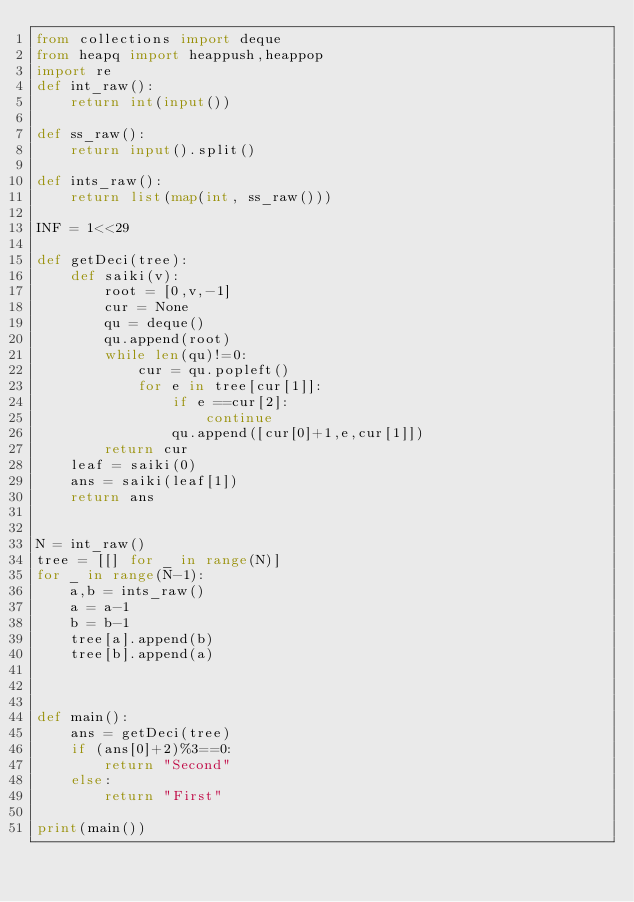Convert code to text. <code><loc_0><loc_0><loc_500><loc_500><_Python_>from collections import deque
from heapq import heappush,heappop
import re
def int_raw():
    return int(input())

def ss_raw():
    return input().split()

def ints_raw():
    return list(map(int, ss_raw()))

INF = 1<<29

def getDeci(tree):
    def saiki(v):
        root = [0,v,-1]
        cur = None
        qu = deque()
        qu.append(root)
        while len(qu)!=0:
            cur = qu.popleft()
            for e in tree[cur[1]]:
                if e ==cur[2]:
                    continue
                qu.append([cur[0]+1,e,cur[1]])
        return cur
    leaf = saiki(0)
    ans = saiki(leaf[1])
    return ans

    
N = int_raw()
tree = [[] for _ in range(N)]
for _ in range(N-1):
    a,b = ints_raw()
    a = a-1
    b = b-1
    tree[a].append(b)
    tree[b].append(a)



def main():
    ans = getDeci(tree)
    if (ans[0]+2)%3==0:
        return "Second"
    else:
        return "First"

print(main())
</code> 